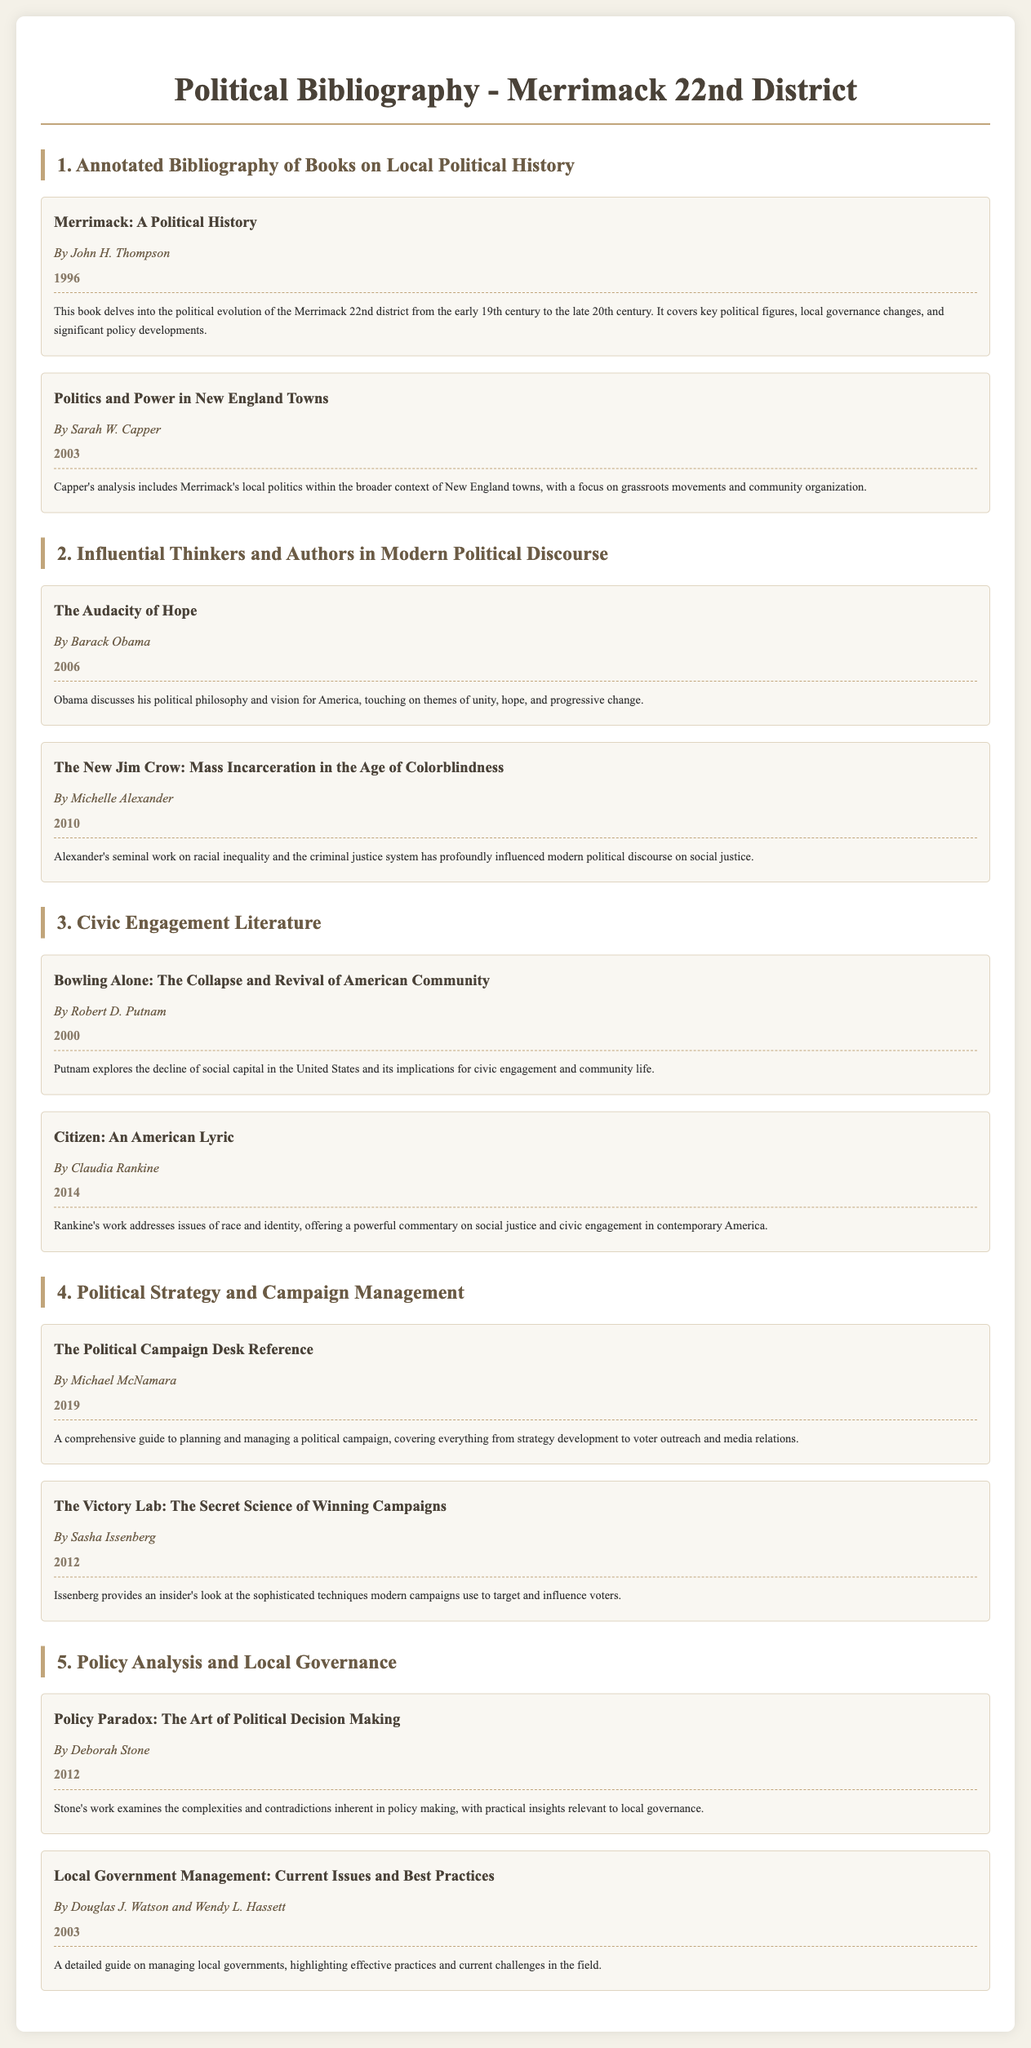What is the title of the first book in the annotated bibliography? The title is listed at the beginning of each entry in the bibliography section, starting with the first book under Local Political History.
Answer: Merrimack: A Political History Who authored "The New Jim Crow"? The author is mentioned directly after the book title in the Influential Thinkers section.
Answer: Michelle Alexander What year was "Bowling Alone" published? The publication year is listed with each book entry in the Civic Engagement Literature section.
Answer: 2000 Which book focuses on modern political campaign strategies? The titles within the Political Strategy and Campaign Management section indicate the focus of each book related to political campaigning.
Answer: The Victory Lab: The Secret Science of Winning Campaigns How many books are listed in the Policy Analysis and Local Governance section? The number of books can be counted based on the entries in the specified section.
Answer: 2 What theme is central to Barack Obama's "The Audacity of Hope"? The summary provides insight into the core ideas discussed in the book, reflecting on political philosophy.
Answer: Unity, hope, and progressive change Which author discusses the decline of social capital in America? The author's name is associated with the book that addresses this sociological concept in the Civic Engagement Literature section.
Answer: Robert D. Putnam What does Deborah Stone's book examine? The summary describes the primary focus of the book and its relevance to local governance challenges.
Answer: The complexities and contradictions in policy making 